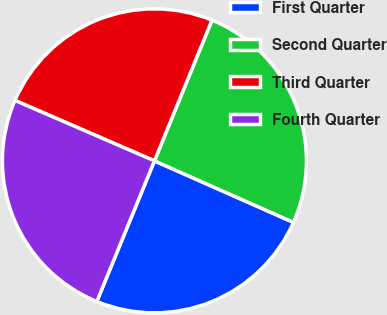<chart> <loc_0><loc_0><loc_500><loc_500><pie_chart><fcel>First Quarter<fcel>Second Quarter<fcel>Third Quarter<fcel>Fourth Quarter<nl><fcel>24.56%<fcel>25.46%<fcel>24.67%<fcel>25.32%<nl></chart> 